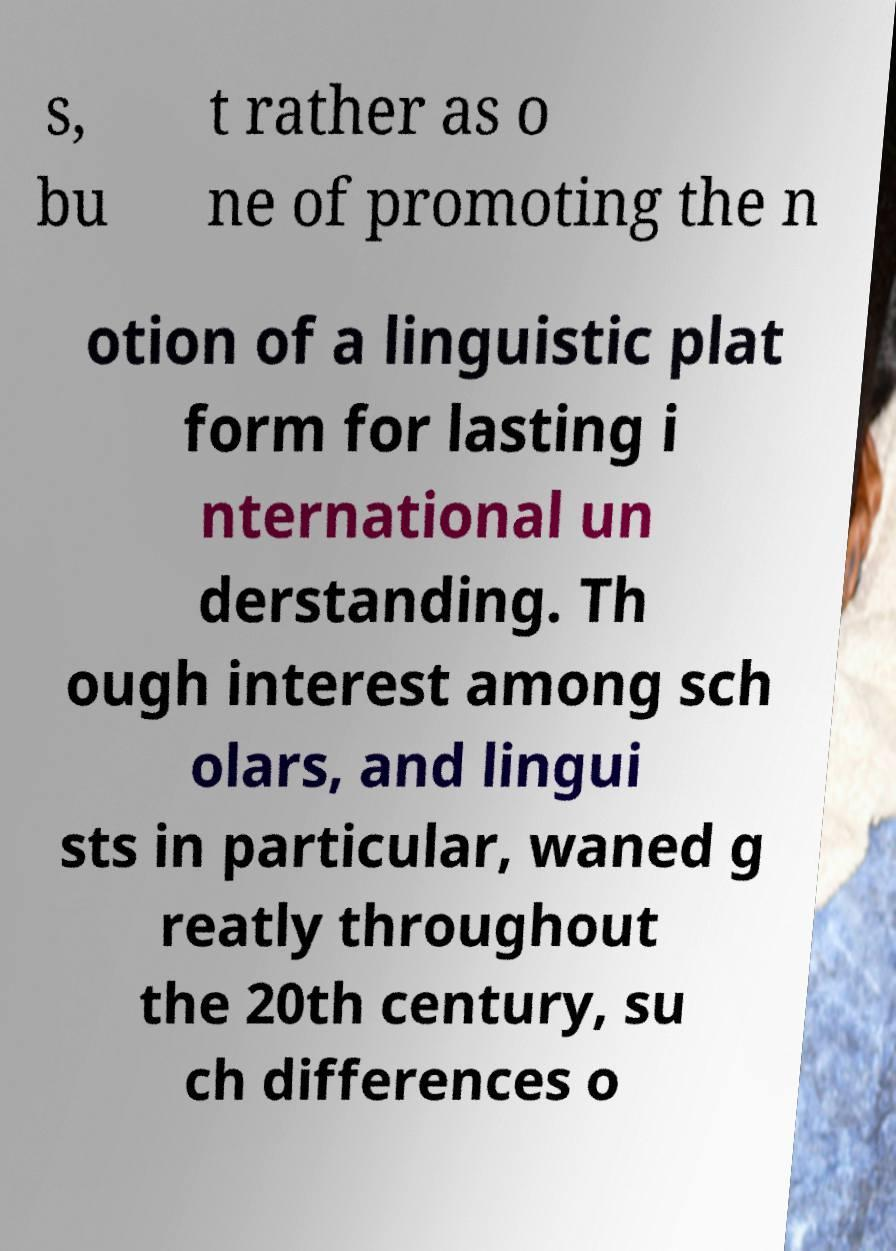I need the written content from this picture converted into text. Can you do that? s, bu t rather as o ne of promoting the n otion of a linguistic plat form for lasting i nternational un derstanding. Th ough interest among sch olars, and lingui sts in particular, waned g reatly throughout the 20th century, su ch differences o 